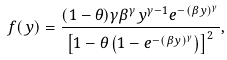<formula> <loc_0><loc_0><loc_500><loc_500>f ( y ) = \frac { ( 1 - \theta ) \gamma \beta ^ { \gamma } y ^ { \gamma - 1 } e ^ { - ( \beta y ) ^ { \gamma } } } { \left [ 1 - \theta \left ( 1 - e ^ { - ( \beta y ) ^ { \gamma } } \right ) \right ] ^ { 2 } } ,</formula> 